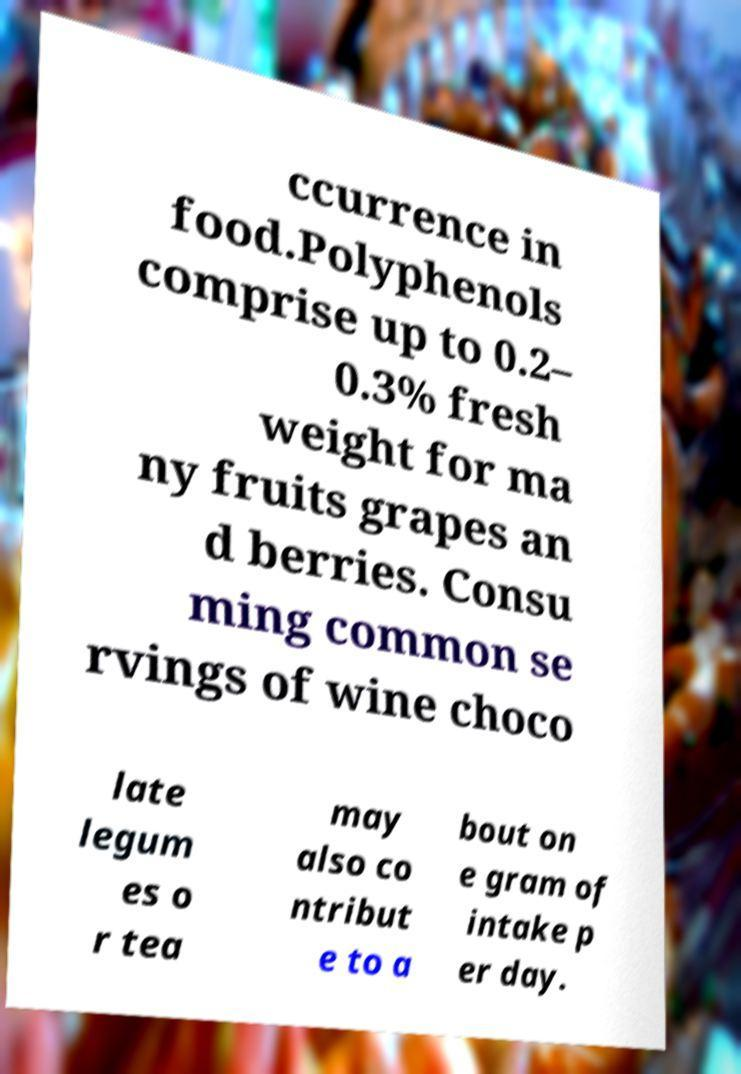Please read and relay the text visible in this image. What does it say? ccurrence in food.Polyphenols comprise up to 0.2– 0.3% fresh weight for ma ny fruits grapes an d berries. Consu ming common se rvings of wine choco late legum es o r tea may also co ntribut e to a bout on e gram of intake p er day. 